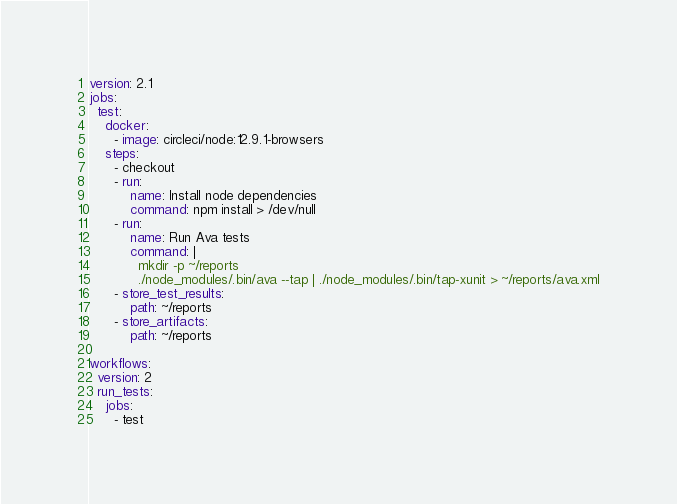<code> <loc_0><loc_0><loc_500><loc_500><_YAML_>version: 2.1
jobs:
  test:
    docker:
      - image: circleci/node:12.9.1-browsers
    steps:
      - checkout
      - run:
          name: Install node dependencies
          command: npm install > /dev/null
      - run:
          name: Run Ava tests
          command: |
            mkdir -p ~/reports
            ./node_modules/.bin/ava --tap | ./node_modules/.bin/tap-xunit > ~/reports/ava.xml
      - store_test_results:
          path: ~/reports
      - store_artifacts:
          path: ~/reports

workflows:
  version: 2
  run_tests:
    jobs:
      - test
</code> 